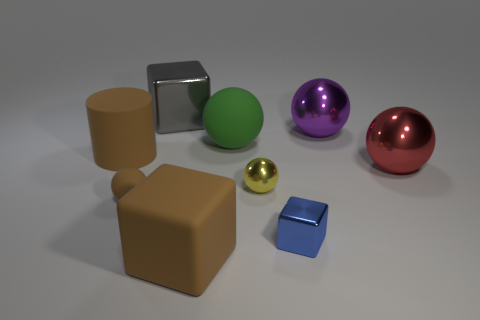Subtract all brown balls. How many balls are left? 4 Subtract all small rubber spheres. How many spheres are left? 4 Subtract all blue balls. Subtract all purple cylinders. How many balls are left? 5 Add 1 large brown matte blocks. How many objects exist? 10 Subtract all balls. How many objects are left? 4 Add 7 big brown matte objects. How many big brown matte objects are left? 9 Add 6 blue cubes. How many blue cubes exist? 7 Subtract 0 cyan balls. How many objects are left? 9 Subtract all tiny gray rubber blocks. Subtract all big red metal objects. How many objects are left? 8 